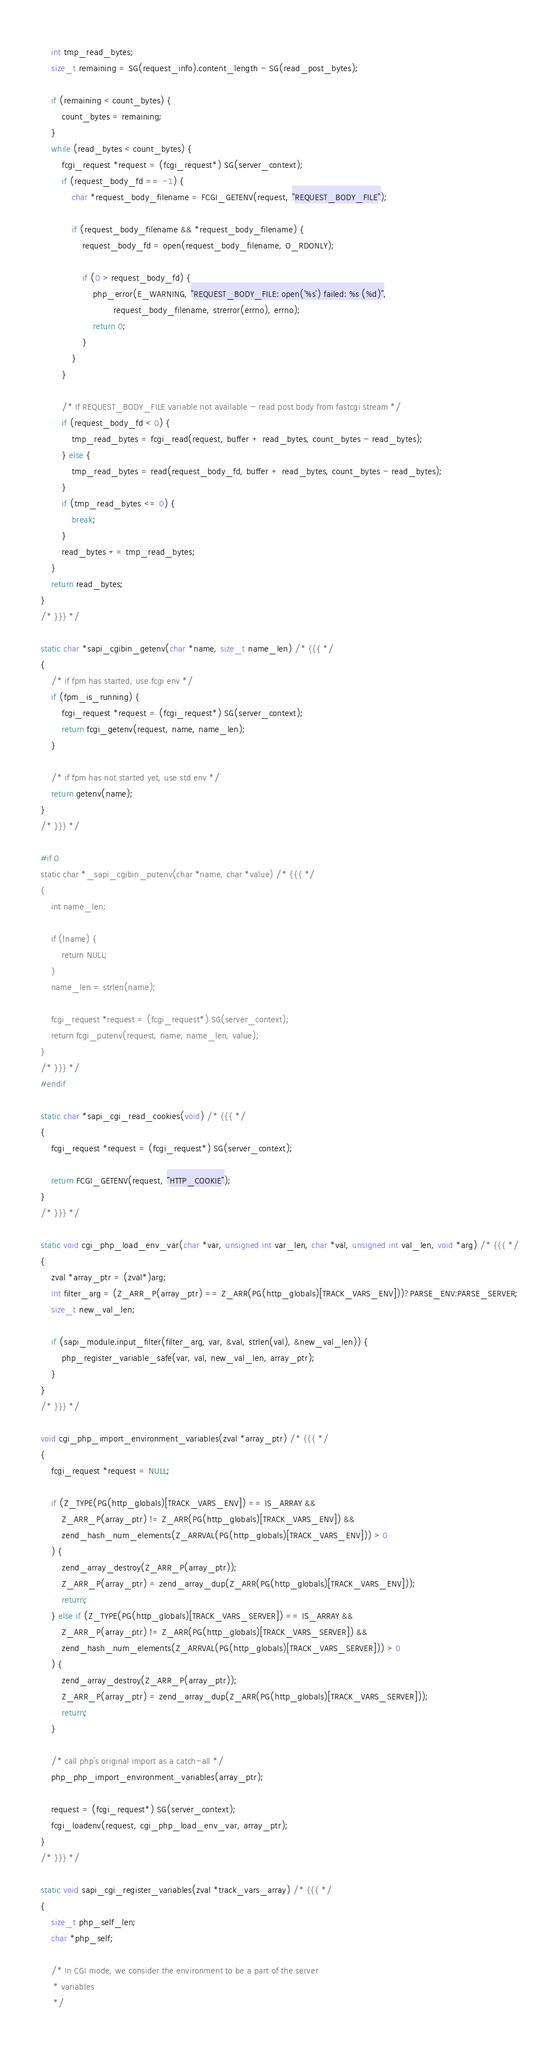<code> <loc_0><loc_0><loc_500><loc_500><_C_>	int tmp_read_bytes;
	size_t remaining = SG(request_info).content_length - SG(read_post_bytes);

	if (remaining < count_bytes) {
		count_bytes = remaining;
	}
	while (read_bytes < count_bytes) {
		fcgi_request *request = (fcgi_request*) SG(server_context);
		if (request_body_fd == -1) {
			char *request_body_filename = FCGI_GETENV(request, "REQUEST_BODY_FILE");

			if (request_body_filename && *request_body_filename) {
				request_body_fd = open(request_body_filename, O_RDONLY);

				if (0 > request_body_fd) {
					php_error(E_WARNING, "REQUEST_BODY_FILE: open('%s') failed: %s (%d)",
							request_body_filename, strerror(errno), errno);
					return 0;
				}
			}
		}

		/* If REQUEST_BODY_FILE variable not available - read post body from fastcgi stream */
		if (request_body_fd < 0) {
			tmp_read_bytes = fcgi_read(request, buffer + read_bytes, count_bytes - read_bytes);
		} else {
			tmp_read_bytes = read(request_body_fd, buffer + read_bytes, count_bytes - read_bytes);
		}
		if (tmp_read_bytes <= 0) {
			break;
		}
		read_bytes += tmp_read_bytes;
	}
	return read_bytes;
}
/* }}} */

static char *sapi_cgibin_getenv(char *name, size_t name_len) /* {{{ */
{
	/* if fpm has started, use fcgi env */
	if (fpm_is_running) {
		fcgi_request *request = (fcgi_request*) SG(server_context);
		return fcgi_getenv(request, name, name_len);
	}

	/* if fpm has not started yet, use std env */
	return getenv(name);
}
/* }}} */

#if 0
static char *_sapi_cgibin_putenv(char *name, char *value) /* {{{ */
{
	int name_len;

	if (!name) {
		return NULL;
	}
	name_len = strlen(name);

	fcgi_request *request = (fcgi_request*) SG(server_context);
	return fcgi_putenv(request, name, name_len, value);
}
/* }}} */
#endif

static char *sapi_cgi_read_cookies(void) /* {{{ */
{
	fcgi_request *request = (fcgi_request*) SG(server_context);

	return FCGI_GETENV(request, "HTTP_COOKIE");
}
/* }}} */

static void cgi_php_load_env_var(char *var, unsigned int var_len, char *val, unsigned int val_len, void *arg) /* {{{ */
{
	zval *array_ptr = (zval*)arg;
	int filter_arg = (Z_ARR_P(array_ptr) == Z_ARR(PG(http_globals)[TRACK_VARS_ENV]))?PARSE_ENV:PARSE_SERVER;
	size_t new_val_len;

	if (sapi_module.input_filter(filter_arg, var, &val, strlen(val), &new_val_len)) {
		php_register_variable_safe(var, val, new_val_len, array_ptr);
	}
}
/* }}} */

void cgi_php_import_environment_variables(zval *array_ptr) /* {{{ */
{
	fcgi_request *request = NULL;

	if (Z_TYPE(PG(http_globals)[TRACK_VARS_ENV]) == IS_ARRAY &&
		Z_ARR_P(array_ptr) != Z_ARR(PG(http_globals)[TRACK_VARS_ENV]) &&
		zend_hash_num_elements(Z_ARRVAL(PG(http_globals)[TRACK_VARS_ENV])) > 0
	) {
		zend_array_destroy(Z_ARR_P(array_ptr));
		Z_ARR_P(array_ptr) = zend_array_dup(Z_ARR(PG(http_globals)[TRACK_VARS_ENV]));
		return;
	} else if (Z_TYPE(PG(http_globals)[TRACK_VARS_SERVER]) == IS_ARRAY &&
		Z_ARR_P(array_ptr) != Z_ARR(PG(http_globals)[TRACK_VARS_SERVER]) &&
		zend_hash_num_elements(Z_ARRVAL(PG(http_globals)[TRACK_VARS_SERVER])) > 0
	) {
		zend_array_destroy(Z_ARR_P(array_ptr));
		Z_ARR_P(array_ptr) = zend_array_dup(Z_ARR(PG(http_globals)[TRACK_VARS_SERVER]));
		return;
	}

	/* call php's original import as a catch-all */
	php_php_import_environment_variables(array_ptr);

	request = (fcgi_request*) SG(server_context);
	fcgi_loadenv(request, cgi_php_load_env_var, array_ptr);
}
/* }}} */

static void sapi_cgi_register_variables(zval *track_vars_array) /* {{{ */
{
	size_t php_self_len;
	char *php_self;

	/* In CGI mode, we consider the environment to be a part of the server
	 * variables
	 */</code> 